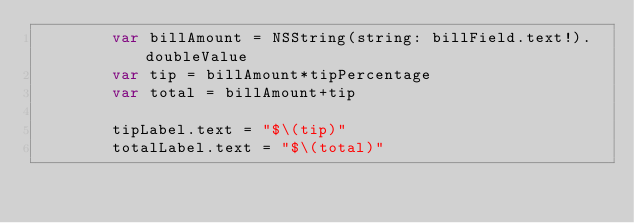<code> <loc_0><loc_0><loc_500><loc_500><_Swift_>        var billAmount = NSString(string: billField.text!).doubleValue
        var tip = billAmount*tipPercentage
        var total = billAmount+tip
        
        tipLabel.text = "$\(tip)"
        totalLabel.text = "$\(total)"
        </code> 